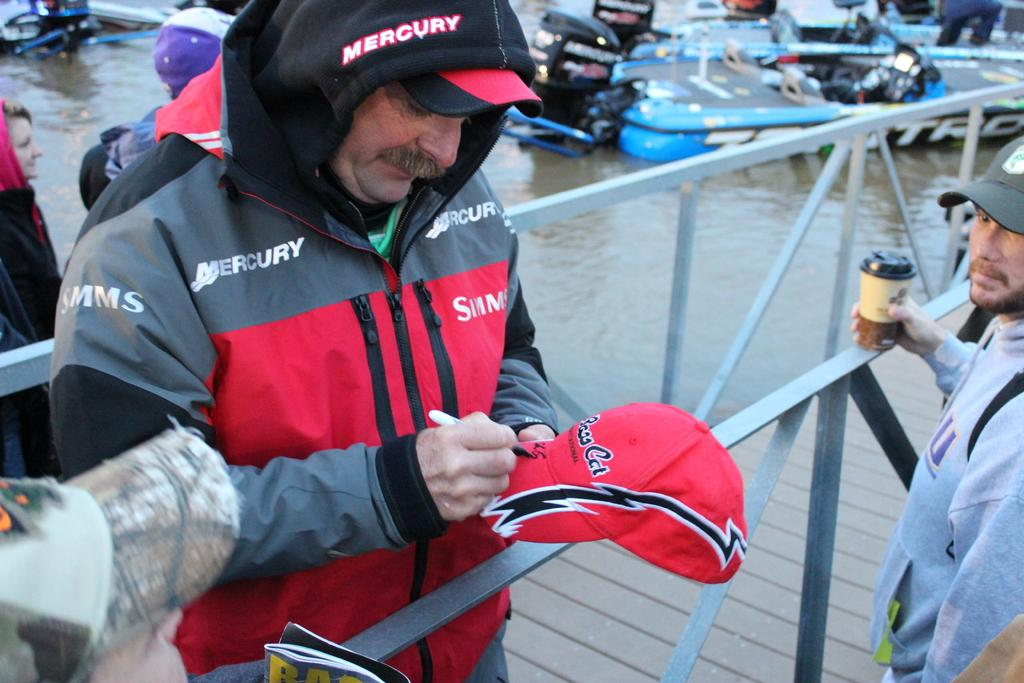How many people are in the image? There are people in the image, but the exact number is not specified. What is the man holding in the image? The man is holding a pen. What is the man doing with the pen? The man is writing on a cap. What can be seen in the background of the image? In the background, there are boats above the water. What is the purpose of the fence in the image? The purpose of the fence is not specified, but it could be for separating areas or providing a barrier. What type of pancake is being served on the level surface in the image? There is no pancake or level surface present in the image. Which type of berry is growing on the fence in the image? There is no mention of berries or any plants growing on the fence in the image. 